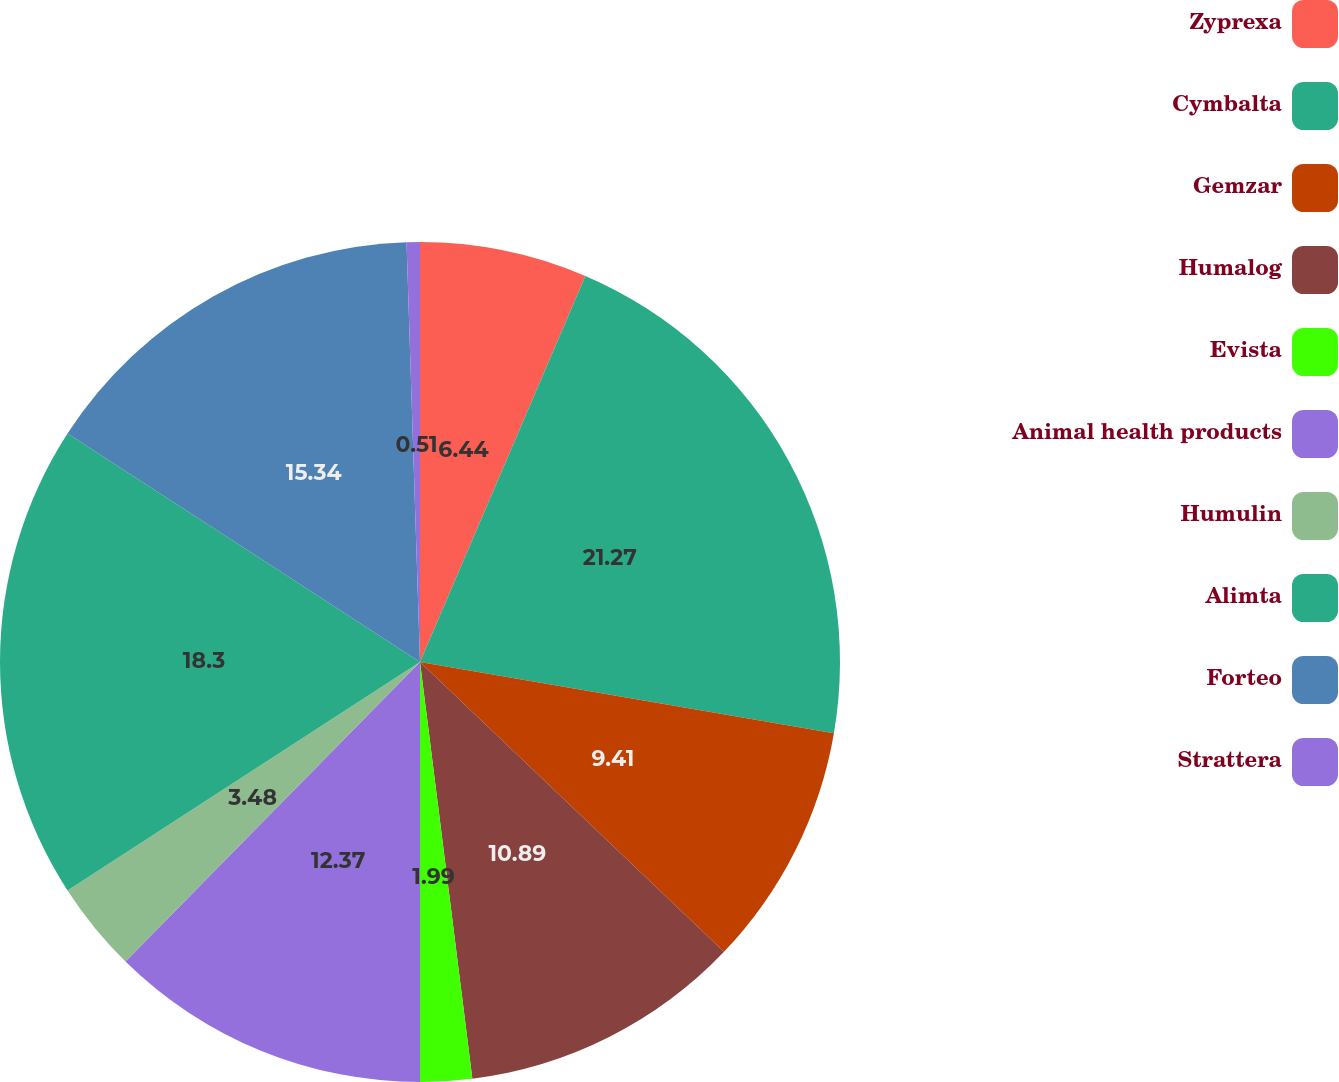Convert chart. <chart><loc_0><loc_0><loc_500><loc_500><pie_chart><fcel>Zyprexa<fcel>Cymbalta<fcel>Gemzar<fcel>Humalog<fcel>Evista<fcel>Animal health products<fcel>Humulin<fcel>Alimta<fcel>Forteo<fcel>Strattera<nl><fcel>6.44%<fcel>21.27%<fcel>9.41%<fcel>10.89%<fcel>1.99%<fcel>12.37%<fcel>3.48%<fcel>18.3%<fcel>15.34%<fcel>0.51%<nl></chart> 